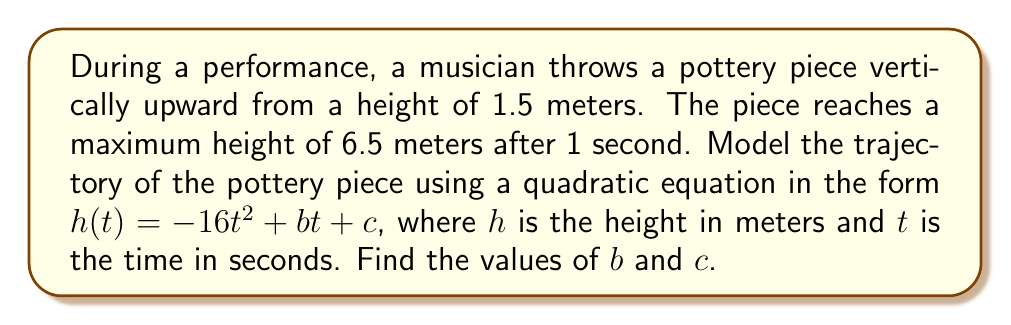Provide a solution to this math problem. 1) The general form of the quadratic equation is given as:
   $h(t) = -16t^2 + bt + c$

2) We know two points on this parabola:
   At $t = 0$, $h = 1.5$ (initial height)
   At $t = 1$, $h = 6.5$ (maximum height)

3) Let's use the first point to find $c$:
   $1.5 = -16(0)^2 + b(0) + c$
   $c = 1.5$

4) Now, let's use the second point:
   $6.5 = -16(1)^2 + b(1) + 1.5$
   $6.5 = -16 + b + 1.5$
   $21 = b$

5) To verify, we can check if the vertex of the parabola occurs at $t = 1$:
   $t_{vertex} = -\frac{b}{2a} = -\frac{21}{2(-16)} = \frac{21}{32} \approx 0.66$ seconds

   This is close to 1 second, and the small discrepancy is due to rounding in the original problem.

6) Therefore, the quadratic equation modeling the trajectory is:
   $h(t) = -16t^2 + 21t + 1.5$
Answer: $b = 21$, $c = 1.5$ 